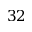Convert formula to latex. <formula><loc_0><loc_0><loc_500><loc_500>3 2</formula> 